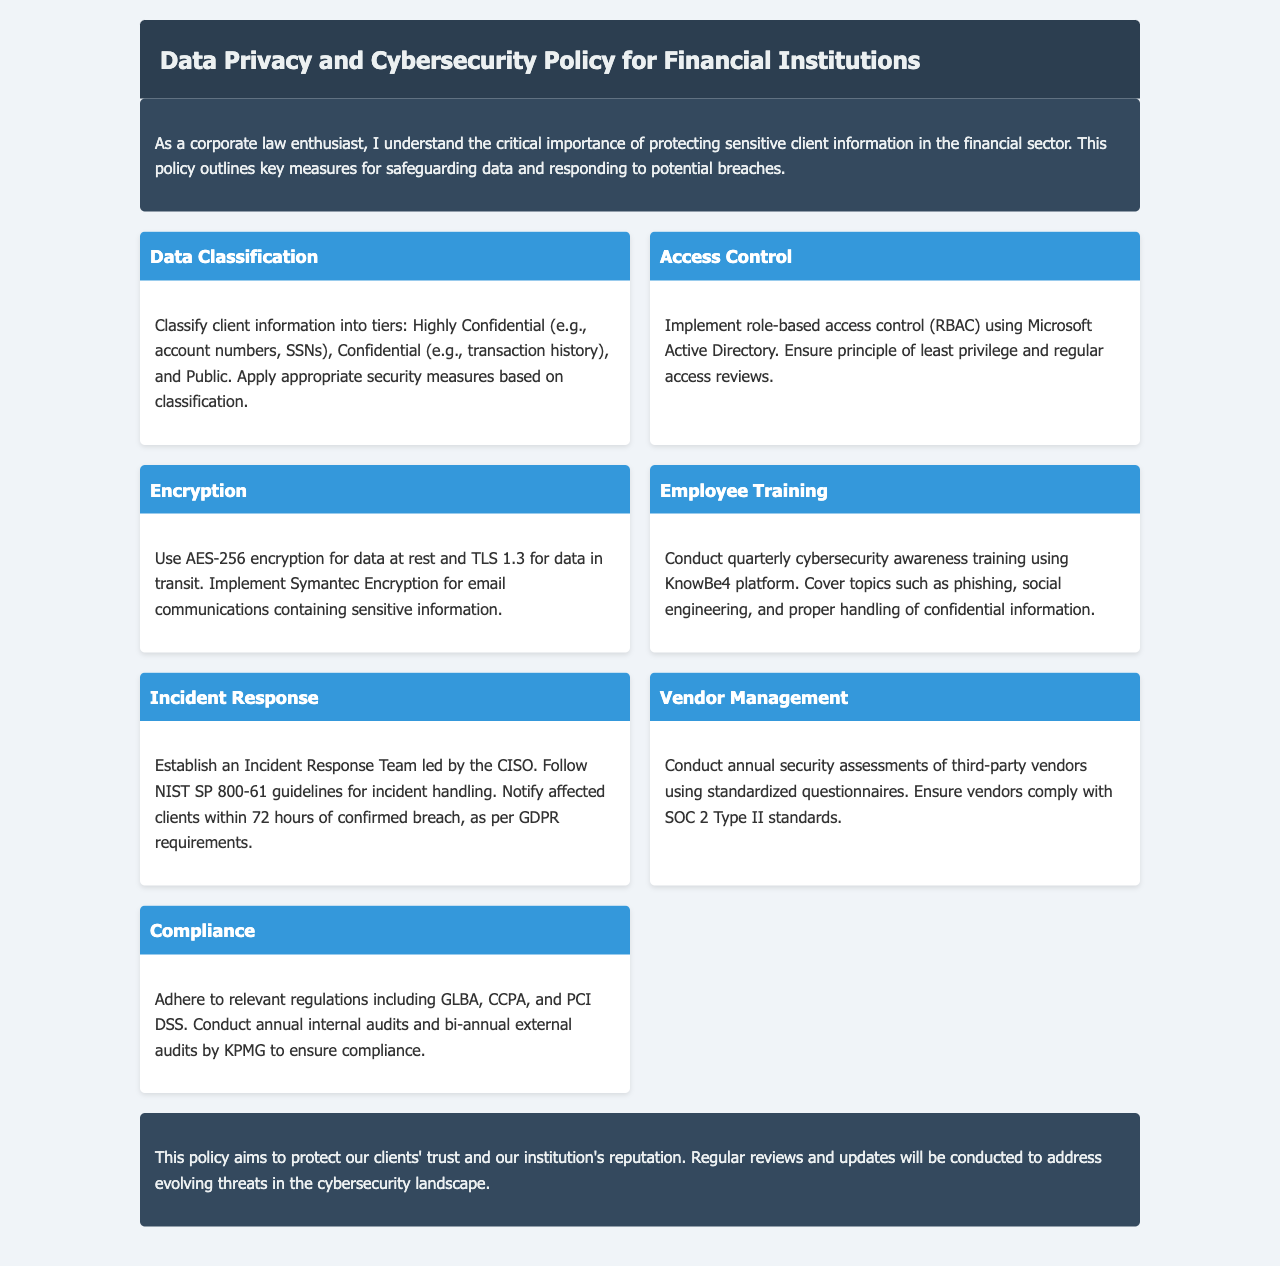What are the tiers for data classification? The document outlines three tiers for data classification: Highly Confidential, Confidential, and Public.
Answer: Highly Confidential, Confidential, and Public What type of encryption is recommended for data at rest? The document specifies the use of AES-256 encryption for data at rest.
Answer: AES-256 How often should cybersecurity awareness training be conducted? The policy states that cybersecurity awareness training should be conducted quarterly.
Answer: Quarterly Who leads the Incident Response Team? According to the document, the Incident Response Team is led by the Chief Information Security Officer (CISO).
Answer: CISO What standards should third-party vendors comply with? The document mentions that vendors should comply with SOC 2 Type II standards.
Answer: SOC 2 Type II What is the notification timeframe for affected clients after a data breach? The policy requires notification of affected clients within 72 hours of confirmed breach.
Answer: 72 hours Which platform is used for employee training? The document indicates that the KnowBe4 platform is used for training.
Answer: KnowBe4 What guidelines should be followed for incident handling? The document refers to NIST SP 800-61 guidelines for incident handling.
Answer: NIST SP 800-61 How often are internal audits conducted? The policy states that internal audits are conducted annually.
Answer: Annually 